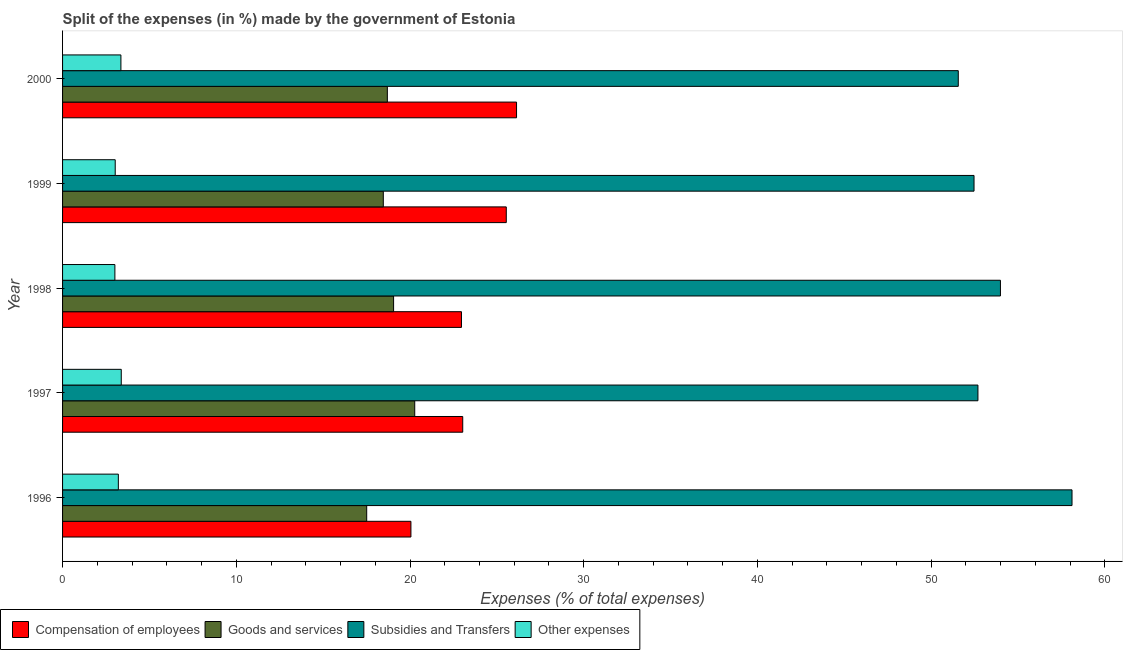Are the number of bars per tick equal to the number of legend labels?
Your answer should be very brief. Yes. Are the number of bars on each tick of the Y-axis equal?
Ensure brevity in your answer.  Yes. How many bars are there on the 2nd tick from the bottom?
Provide a short and direct response. 4. What is the label of the 4th group of bars from the top?
Your answer should be very brief. 1997. What is the percentage of amount spent on compensation of employees in 2000?
Ensure brevity in your answer.  26.13. Across all years, what is the maximum percentage of amount spent on goods and services?
Your answer should be compact. 20.27. Across all years, what is the minimum percentage of amount spent on other expenses?
Your answer should be compact. 3.01. What is the total percentage of amount spent on compensation of employees in the graph?
Your answer should be very brief. 117.72. What is the difference between the percentage of amount spent on compensation of employees in 1996 and that in 1997?
Ensure brevity in your answer.  -2.98. What is the difference between the percentage of amount spent on other expenses in 1997 and the percentage of amount spent on goods and services in 1999?
Your response must be concise. -15.08. What is the average percentage of amount spent on subsidies per year?
Provide a short and direct response. 53.76. In the year 1999, what is the difference between the percentage of amount spent on compensation of employees and percentage of amount spent on goods and services?
Offer a very short reply. 7.08. What is the ratio of the percentage of amount spent on subsidies in 1997 to that in 2000?
Provide a short and direct response. 1.02. Is the percentage of amount spent on goods and services in 1998 less than that in 2000?
Your response must be concise. No. What is the difference between the highest and the second highest percentage of amount spent on goods and services?
Offer a very short reply. 1.22. What is the difference between the highest and the lowest percentage of amount spent on subsidies?
Keep it short and to the point. 6.55. In how many years, is the percentage of amount spent on goods and services greater than the average percentage of amount spent on goods and services taken over all years?
Your answer should be very brief. 2. Is the sum of the percentage of amount spent on compensation of employees in 1998 and 1999 greater than the maximum percentage of amount spent on goods and services across all years?
Your response must be concise. Yes. What does the 2nd bar from the top in 1999 represents?
Provide a short and direct response. Subsidies and Transfers. What does the 4th bar from the bottom in 1997 represents?
Offer a very short reply. Other expenses. How many bars are there?
Keep it short and to the point. 20. Are all the bars in the graph horizontal?
Offer a terse response. Yes. How many years are there in the graph?
Your response must be concise. 5. Are the values on the major ticks of X-axis written in scientific E-notation?
Offer a very short reply. No. Does the graph contain grids?
Give a very brief answer. No. Where does the legend appear in the graph?
Keep it short and to the point. Bottom left. How many legend labels are there?
Your answer should be very brief. 4. How are the legend labels stacked?
Provide a short and direct response. Horizontal. What is the title of the graph?
Make the answer very short. Split of the expenses (in %) made by the government of Estonia. Does "Public resource use" appear as one of the legend labels in the graph?
Offer a very short reply. No. What is the label or title of the X-axis?
Your answer should be very brief. Expenses (% of total expenses). What is the Expenses (% of total expenses) in Compensation of employees in 1996?
Give a very brief answer. 20.05. What is the Expenses (% of total expenses) of Goods and services in 1996?
Offer a very short reply. 17.51. What is the Expenses (% of total expenses) in Subsidies and Transfers in 1996?
Keep it short and to the point. 58.11. What is the Expenses (% of total expenses) of Other expenses in 1996?
Make the answer very short. 3.21. What is the Expenses (% of total expenses) in Compensation of employees in 1997?
Offer a terse response. 23.03. What is the Expenses (% of total expenses) in Goods and services in 1997?
Keep it short and to the point. 20.27. What is the Expenses (% of total expenses) of Subsidies and Transfers in 1997?
Provide a succinct answer. 52.69. What is the Expenses (% of total expenses) of Other expenses in 1997?
Offer a terse response. 3.38. What is the Expenses (% of total expenses) of Compensation of employees in 1998?
Offer a terse response. 22.96. What is the Expenses (% of total expenses) of Goods and services in 1998?
Make the answer very short. 19.05. What is the Expenses (% of total expenses) of Subsidies and Transfers in 1998?
Keep it short and to the point. 53.99. What is the Expenses (% of total expenses) of Other expenses in 1998?
Offer a very short reply. 3.01. What is the Expenses (% of total expenses) in Compensation of employees in 1999?
Keep it short and to the point. 25.54. What is the Expenses (% of total expenses) in Goods and services in 1999?
Your response must be concise. 18.46. What is the Expenses (% of total expenses) in Subsidies and Transfers in 1999?
Provide a succinct answer. 52.47. What is the Expenses (% of total expenses) of Other expenses in 1999?
Offer a terse response. 3.03. What is the Expenses (% of total expenses) of Compensation of employees in 2000?
Your response must be concise. 26.13. What is the Expenses (% of total expenses) of Goods and services in 2000?
Offer a very short reply. 18.7. What is the Expenses (% of total expenses) in Subsidies and Transfers in 2000?
Your answer should be very brief. 51.56. What is the Expenses (% of total expenses) of Other expenses in 2000?
Your answer should be very brief. 3.36. Across all years, what is the maximum Expenses (% of total expenses) in Compensation of employees?
Make the answer very short. 26.13. Across all years, what is the maximum Expenses (% of total expenses) in Goods and services?
Ensure brevity in your answer.  20.27. Across all years, what is the maximum Expenses (% of total expenses) of Subsidies and Transfers?
Offer a very short reply. 58.11. Across all years, what is the maximum Expenses (% of total expenses) in Other expenses?
Make the answer very short. 3.38. Across all years, what is the minimum Expenses (% of total expenses) in Compensation of employees?
Keep it short and to the point. 20.05. Across all years, what is the minimum Expenses (% of total expenses) of Goods and services?
Your answer should be compact. 17.51. Across all years, what is the minimum Expenses (% of total expenses) of Subsidies and Transfers?
Your answer should be very brief. 51.56. Across all years, what is the minimum Expenses (% of total expenses) in Other expenses?
Make the answer very short. 3.01. What is the total Expenses (% of total expenses) of Compensation of employees in the graph?
Provide a short and direct response. 117.72. What is the total Expenses (% of total expenses) of Goods and services in the graph?
Offer a very short reply. 93.99. What is the total Expenses (% of total expenses) of Subsidies and Transfers in the graph?
Your answer should be compact. 268.81. What is the total Expenses (% of total expenses) of Other expenses in the graph?
Provide a short and direct response. 15.99. What is the difference between the Expenses (% of total expenses) in Compensation of employees in 1996 and that in 1997?
Offer a very short reply. -2.98. What is the difference between the Expenses (% of total expenses) in Goods and services in 1996 and that in 1997?
Give a very brief answer. -2.76. What is the difference between the Expenses (% of total expenses) of Subsidies and Transfers in 1996 and that in 1997?
Ensure brevity in your answer.  5.42. What is the difference between the Expenses (% of total expenses) in Other expenses in 1996 and that in 1997?
Provide a succinct answer. -0.17. What is the difference between the Expenses (% of total expenses) in Compensation of employees in 1996 and that in 1998?
Provide a succinct answer. -2.91. What is the difference between the Expenses (% of total expenses) of Goods and services in 1996 and that in 1998?
Give a very brief answer. -1.55. What is the difference between the Expenses (% of total expenses) in Subsidies and Transfers in 1996 and that in 1998?
Your answer should be very brief. 4.12. What is the difference between the Expenses (% of total expenses) in Other expenses in 1996 and that in 1998?
Keep it short and to the point. 0.2. What is the difference between the Expenses (% of total expenses) of Compensation of employees in 1996 and that in 1999?
Make the answer very short. -5.49. What is the difference between the Expenses (% of total expenses) of Goods and services in 1996 and that in 1999?
Ensure brevity in your answer.  -0.96. What is the difference between the Expenses (% of total expenses) of Subsidies and Transfers in 1996 and that in 1999?
Your answer should be very brief. 5.64. What is the difference between the Expenses (% of total expenses) in Other expenses in 1996 and that in 1999?
Give a very brief answer. 0.18. What is the difference between the Expenses (% of total expenses) in Compensation of employees in 1996 and that in 2000?
Provide a short and direct response. -6.08. What is the difference between the Expenses (% of total expenses) of Goods and services in 1996 and that in 2000?
Your response must be concise. -1.19. What is the difference between the Expenses (% of total expenses) in Subsidies and Transfers in 1996 and that in 2000?
Your answer should be compact. 6.55. What is the difference between the Expenses (% of total expenses) in Other expenses in 1996 and that in 2000?
Ensure brevity in your answer.  -0.15. What is the difference between the Expenses (% of total expenses) in Compensation of employees in 1997 and that in 1998?
Your answer should be very brief. 0.07. What is the difference between the Expenses (% of total expenses) of Goods and services in 1997 and that in 1998?
Give a very brief answer. 1.22. What is the difference between the Expenses (% of total expenses) of Subsidies and Transfers in 1997 and that in 1998?
Provide a short and direct response. -1.3. What is the difference between the Expenses (% of total expenses) in Other expenses in 1997 and that in 1998?
Your response must be concise. 0.37. What is the difference between the Expenses (% of total expenses) of Compensation of employees in 1997 and that in 1999?
Ensure brevity in your answer.  -2.51. What is the difference between the Expenses (% of total expenses) of Goods and services in 1997 and that in 1999?
Provide a succinct answer. 1.81. What is the difference between the Expenses (% of total expenses) in Subsidies and Transfers in 1997 and that in 1999?
Make the answer very short. 0.22. What is the difference between the Expenses (% of total expenses) of Other expenses in 1997 and that in 1999?
Your answer should be compact. 0.35. What is the difference between the Expenses (% of total expenses) in Compensation of employees in 1997 and that in 2000?
Give a very brief answer. -3.1. What is the difference between the Expenses (% of total expenses) of Goods and services in 1997 and that in 2000?
Your answer should be very brief. 1.58. What is the difference between the Expenses (% of total expenses) in Subsidies and Transfers in 1997 and that in 2000?
Ensure brevity in your answer.  1.13. What is the difference between the Expenses (% of total expenses) in Other expenses in 1997 and that in 2000?
Provide a short and direct response. 0.02. What is the difference between the Expenses (% of total expenses) in Compensation of employees in 1998 and that in 1999?
Make the answer very short. -2.58. What is the difference between the Expenses (% of total expenses) in Goods and services in 1998 and that in 1999?
Make the answer very short. 0.59. What is the difference between the Expenses (% of total expenses) in Subsidies and Transfers in 1998 and that in 1999?
Offer a very short reply. 1.52. What is the difference between the Expenses (% of total expenses) in Other expenses in 1998 and that in 1999?
Your answer should be compact. -0.02. What is the difference between the Expenses (% of total expenses) in Compensation of employees in 1998 and that in 2000?
Your answer should be very brief. -3.17. What is the difference between the Expenses (% of total expenses) of Goods and services in 1998 and that in 2000?
Offer a very short reply. 0.36. What is the difference between the Expenses (% of total expenses) of Subsidies and Transfers in 1998 and that in 2000?
Give a very brief answer. 2.43. What is the difference between the Expenses (% of total expenses) of Other expenses in 1998 and that in 2000?
Ensure brevity in your answer.  -0.35. What is the difference between the Expenses (% of total expenses) of Compensation of employees in 1999 and that in 2000?
Offer a very short reply. -0.59. What is the difference between the Expenses (% of total expenses) of Goods and services in 1999 and that in 2000?
Offer a very short reply. -0.23. What is the difference between the Expenses (% of total expenses) in Subsidies and Transfers in 1999 and that in 2000?
Your answer should be compact. 0.91. What is the difference between the Expenses (% of total expenses) in Other expenses in 1999 and that in 2000?
Provide a short and direct response. -0.33. What is the difference between the Expenses (% of total expenses) of Compensation of employees in 1996 and the Expenses (% of total expenses) of Goods and services in 1997?
Give a very brief answer. -0.22. What is the difference between the Expenses (% of total expenses) of Compensation of employees in 1996 and the Expenses (% of total expenses) of Subsidies and Transfers in 1997?
Your answer should be compact. -32.64. What is the difference between the Expenses (% of total expenses) of Compensation of employees in 1996 and the Expenses (% of total expenses) of Other expenses in 1997?
Provide a short and direct response. 16.67. What is the difference between the Expenses (% of total expenses) of Goods and services in 1996 and the Expenses (% of total expenses) of Subsidies and Transfers in 1997?
Make the answer very short. -35.18. What is the difference between the Expenses (% of total expenses) in Goods and services in 1996 and the Expenses (% of total expenses) in Other expenses in 1997?
Your response must be concise. 14.13. What is the difference between the Expenses (% of total expenses) in Subsidies and Transfers in 1996 and the Expenses (% of total expenses) in Other expenses in 1997?
Keep it short and to the point. 54.73. What is the difference between the Expenses (% of total expenses) in Compensation of employees in 1996 and the Expenses (% of total expenses) in Goods and services in 1998?
Make the answer very short. 1. What is the difference between the Expenses (% of total expenses) of Compensation of employees in 1996 and the Expenses (% of total expenses) of Subsidies and Transfers in 1998?
Offer a terse response. -33.93. What is the difference between the Expenses (% of total expenses) in Compensation of employees in 1996 and the Expenses (% of total expenses) in Other expenses in 1998?
Provide a short and direct response. 17.04. What is the difference between the Expenses (% of total expenses) of Goods and services in 1996 and the Expenses (% of total expenses) of Subsidies and Transfers in 1998?
Ensure brevity in your answer.  -36.48. What is the difference between the Expenses (% of total expenses) in Goods and services in 1996 and the Expenses (% of total expenses) in Other expenses in 1998?
Your response must be concise. 14.5. What is the difference between the Expenses (% of total expenses) in Subsidies and Transfers in 1996 and the Expenses (% of total expenses) in Other expenses in 1998?
Your answer should be very brief. 55.1. What is the difference between the Expenses (% of total expenses) of Compensation of employees in 1996 and the Expenses (% of total expenses) of Goods and services in 1999?
Ensure brevity in your answer.  1.59. What is the difference between the Expenses (% of total expenses) in Compensation of employees in 1996 and the Expenses (% of total expenses) in Subsidies and Transfers in 1999?
Give a very brief answer. -32.41. What is the difference between the Expenses (% of total expenses) of Compensation of employees in 1996 and the Expenses (% of total expenses) of Other expenses in 1999?
Keep it short and to the point. 17.02. What is the difference between the Expenses (% of total expenses) of Goods and services in 1996 and the Expenses (% of total expenses) of Subsidies and Transfers in 1999?
Offer a very short reply. -34.96. What is the difference between the Expenses (% of total expenses) in Goods and services in 1996 and the Expenses (% of total expenses) in Other expenses in 1999?
Offer a very short reply. 14.48. What is the difference between the Expenses (% of total expenses) of Subsidies and Transfers in 1996 and the Expenses (% of total expenses) of Other expenses in 1999?
Offer a very short reply. 55.08. What is the difference between the Expenses (% of total expenses) of Compensation of employees in 1996 and the Expenses (% of total expenses) of Goods and services in 2000?
Your response must be concise. 1.36. What is the difference between the Expenses (% of total expenses) in Compensation of employees in 1996 and the Expenses (% of total expenses) in Subsidies and Transfers in 2000?
Provide a short and direct response. -31.51. What is the difference between the Expenses (% of total expenses) of Compensation of employees in 1996 and the Expenses (% of total expenses) of Other expenses in 2000?
Provide a succinct answer. 16.69. What is the difference between the Expenses (% of total expenses) in Goods and services in 1996 and the Expenses (% of total expenses) in Subsidies and Transfers in 2000?
Make the answer very short. -34.05. What is the difference between the Expenses (% of total expenses) of Goods and services in 1996 and the Expenses (% of total expenses) of Other expenses in 2000?
Make the answer very short. 14.15. What is the difference between the Expenses (% of total expenses) of Subsidies and Transfers in 1996 and the Expenses (% of total expenses) of Other expenses in 2000?
Provide a succinct answer. 54.75. What is the difference between the Expenses (% of total expenses) of Compensation of employees in 1997 and the Expenses (% of total expenses) of Goods and services in 1998?
Your answer should be compact. 3.98. What is the difference between the Expenses (% of total expenses) in Compensation of employees in 1997 and the Expenses (% of total expenses) in Subsidies and Transfers in 1998?
Give a very brief answer. -30.95. What is the difference between the Expenses (% of total expenses) in Compensation of employees in 1997 and the Expenses (% of total expenses) in Other expenses in 1998?
Offer a terse response. 20.02. What is the difference between the Expenses (% of total expenses) of Goods and services in 1997 and the Expenses (% of total expenses) of Subsidies and Transfers in 1998?
Your answer should be very brief. -33.72. What is the difference between the Expenses (% of total expenses) of Goods and services in 1997 and the Expenses (% of total expenses) of Other expenses in 1998?
Your answer should be very brief. 17.26. What is the difference between the Expenses (% of total expenses) of Subsidies and Transfers in 1997 and the Expenses (% of total expenses) of Other expenses in 1998?
Give a very brief answer. 49.68. What is the difference between the Expenses (% of total expenses) of Compensation of employees in 1997 and the Expenses (% of total expenses) of Goods and services in 1999?
Make the answer very short. 4.57. What is the difference between the Expenses (% of total expenses) of Compensation of employees in 1997 and the Expenses (% of total expenses) of Subsidies and Transfers in 1999?
Offer a terse response. -29.43. What is the difference between the Expenses (% of total expenses) in Compensation of employees in 1997 and the Expenses (% of total expenses) in Other expenses in 1999?
Offer a terse response. 20. What is the difference between the Expenses (% of total expenses) in Goods and services in 1997 and the Expenses (% of total expenses) in Subsidies and Transfers in 1999?
Offer a terse response. -32.2. What is the difference between the Expenses (% of total expenses) of Goods and services in 1997 and the Expenses (% of total expenses) of Other expenses in 1999?
Offer a terse response. 17.24. What is the difference between the Expenses (% of total expenses) of Subsidies and Transfers in 1997 and the Expenses (% of total expenses) of Other expenses in 1999?
Keep it short and to the point. 49.66. What is the difference between the Expenses (% of total expenses) in Compensation of employees in 1997 and the Expenses (% of total expenses) in Goods and services in 2000?
Make the answer very short. 4.34. What is the difference between the Expenses (% of total expenses) in Compensation of employees in 1997 and the Expenses (% of total expenses) in Subsidies and Transfers in 2000?
Ensure brevity in your answer.  -28.53. What is the difference between the Expenses (% of total expenses) of Compensation of employees in 1997 and the Expenses (% of total expenses) of Other expenses in 2000?
Keep it short and to the point. 19.68. What is the difference between the Expenses (% of total expenses) of Goods and services in 1997 and the Expenses (% of total expenses) of Subsidies and Transfers in 2000?
Your answer should be compact. -31.29. What is the difference between the Expenses (% of total expenses) of Goods and services in 1997 and the Expenses (% of total expenses) of Other expenses in 2000?
Offer a very short reply. 16.91. What is the difference between the Expenses (% of total expenses) of Subsidies and Transfers in 1997 and the Expenses (% of total expenses) of Other expenses in 2000?
Give a very brief answer. 49.33. What is the difference between the Expenses (% of total expenses) of Compensation of employees in 1998 and the Expenses (% of total expenses) of Goods and services in 1999?
Offer a terse response. 4.5. What is the difference between the Expenses (% of total expenses) in Compensation of employees in 1998 and the Expenses (% of total expenses) in Subsidies and Transfers in 1999?
Offer a terse response. -29.51. What is the difference between the Expenses (% of total expenses) in Compensation of employees in 1998 and the Expenses (% of total expenses) in Other expenses in 1999?
Keep it short and to the point. 19.93. What is the difference between the Expenses (% of total expenses) of Goods and services in 1998 and the Expenses (% of total expenses) of Subsidies and Transfers in 1999?
Your answer should be compact. -33.41. What is the difference between the Expenses (% of total expenses) in Goods and services in 1998 and the Expenses (% of total expenses) in Other expenses in 1999?
Ensure brevity in your answer.  16.02. What is the difference between the Expenses (% of total expenses) in Subsidies and Transfers in 1998 and the Expenses (% of total expenses) in Other expenses in 1999?
Give a very brief answer. 50.96. What is the difference between the Expenses (% of total expenses) of Compensation of employees in 1998 and the Expenses (% of total expenses) of Goods and services in 2000?
Offer a terse response. 4.27. What is the difference between the Expenses (% of total expenses) of Compensation of employees in 1998 and the Expenses (% of total expenses) of Subsidies and Transfers in 2000?
Your answer should be compact. -28.6. What is the difference between the Expenses (% of total expenses) in Compensation of employees in 1998 and the Expenses (% of total expenses) in Other expenses in 2000?
Your answer should be very brief. 19.6. What is the difference between the Expenses (% of total expenses) of Goods and services in 1998 and the Expenses (% of total expenses) of Subsidies and Transfers in 2000?
Give a very brief answer. -32.51. What is the difference between the Expenses (% of total expenses) of Goods and services in 1998 and the Expenses (% of total expenses) of Other expenses in 2000?
Your response must be concise. 15.7. What is the difference between the Expenses (% of total expenses) of Subsidies and Transfers in 1998 and the Expenses (% of total expenses) of Other expenses in 2000?
Your answer should be very brief. 50.63. What is the difference between the Expenses (% of total expenses) of Compensation of employees in 1999 and the Expenses (% of total expenses) of Goods and services in 2000?
Offer a very short reply. 6.85. What is the difference between the Expenses (% of total expenses) in Compensation of employees in 1999 and the Expenses (% of total expenses) in Subsidies and Transfers in 2000?
Provide a short and direct response. -26.02. What is the difference between the Expenses (% of total expenses) of Compensation of employees in 1999 and the Expenses (% of total expenses) of Other expenses in 2000?
Give a very brief answer. 22.18. What is the difference between the Expenses (% of total expenses) of Goods and services in 1999 and the Expenses (% of total expenses) of Subsidies and Transfers in 2000?
Provide a short and direct response. -33.1. What is the difference between the Expenses (% of total expenses) in Goods and services in 1999 and the Expenses (% of total expenses) in Other expenses in 2000?
Offer a very short reply. 15.1. What is the difference between the Expenses (% of total expenses) of Subsidies and Transfers in 1999 and the Expenses (% of total expenses) of Other expenses in 2000?
Provide a short and direct response. 49.11. What is the average Expenses (% of total expenses) in Compensation of employees per year?
Your answer should be very brief. 23.54. What is the average Expenses (% of total expenses) in Goods and services per year?
Your response must be concise. 18.8. What is the average Expenses (% of total expenses) in Subsidies and Transfers per year?
Provide a short and direct response. 53.76. What is the average Expenses (% of total expenses) in Other expenses per year?
Keep it short and to the point. 3.2. In the year 1996, what is the difference between the Expenses (% of total expenses) in Compensation of employees and Expenses (% of total expenses) in Goods and services?
Keep it short and to the point. 2.55. In the year 1996, what is the difference between the Expenses (% of total expenses) in Compensation of employees and Expenses (% of total expenses) in Subsidies and Transfers?
Offer a very short reply. -38.06. In the year 1996, what is the difference between the Expenses (% of total expenses) of Compensation of employees and Expenses (% of total expenses) of Other expenses?
Keep it short and to the point. 16.84. In the year 1996, what is the difference between the Expenses (% of total expenses) of Goods and services and Expenses (% of total expenses) of Subsidies and Transfers?
Provide a succinct answer. -40.6. In the year 1996, what is the difference between the Expenses (% of total expenses) in Goods and services and Expenses (% of total expenses) in Other expenses?
Make the answer very short. 14.3. In the year 1996, what is the difference between the Expenses (% of total expenses) of Subsidies and Transfers and Expenses (% of total expenses) of Other expenses?
Provide a short and direct response. 54.9. In the year 1997, what is the difference between the Expenses (% of total expenses) of Compensation of employees and Expenses (% of total expenses) of Goods and services?
Provide a short and direct response. 2.76. In the year 1997, what is the difference between the Expenses (% of total expenses) in Compensation of employees and Expenses (% of total expenses) in Subsidies and Transfers?
Provide a short and direct response. -29.66. In the year 1997, what is the difference between the Expenses (% of total expenses) of Compensation of employees and Expenses (% of total expenses) of Other expenses?
Offer a terse response. 19.66. In the year 1997, what is the difference between the Expenses (% of total expenses) of Goods and services and Expenses (% of total expenses) of Subsidies and Transfers?
Your response must be concise. -32.42. In the year 1997, what is the difference between the Expenses (% of total expenses) in Goods and services and Expenses (% of total expenses) in Other expenses?
Your answer should be compact. 16.89. In the year 1997, what is the difference between the Expenses (% of total expenses) in Subsidies and Transfers and Expenses (% of total expenses) in Other expenses?
Provide a succinct answer. 49.31. In the year 1998, what is the difference between the Expenses (% of total expenses) in Compensation of employees and Expenses (% of total expenses) in Goods and services?
Provide a short and direct response. 3.91. In the year 1998, what is the difference between the Expenses (% of total expenses) in Compensation of employees and Expenses (% of total expenses) in Subsidies and Transfers?
Make the answer very short. -31.02. In the year 1998, what is the difference between the Expenses (% of total expenses) of Compensation of employees and Expenses (% of total expenses) of Other expenses?
Give a very brief answer. 19.95. In the year 1998, what is the difference between the Expenses (% of total expenses) in Goods and services and Expenses (% of total expenses) in Subsidies and Transfers?
Keep it short and to the point. -34.93. In the year 1998, what is the difference between the Expenses (% of total expenses) of Goods and services and Expenses (% of total expenses) of Other expenses?
Your answer should be very brief. 16.04. In the year 1998, what is the difference between the Expenses (% of total expenses) of Subsidies and Transfers and Expenses (% of total expenses) of Other expenses?
Your answer should be compact. 50.98. In the year 1999, what is the difference between the Expenses (% of total expenses) in Compensation of employees and Expenses (% of total expenses) in Goods and services?
Your response must be concise. 7.08. In the year 1999, what is the difference between the Expenses (% of total expenses) in Compensation of employees and Expenses (% of total expenses) in Subsidies and Transfers?
Your response must be concise. -26.93. In the year 1999, what is the difference between the Expenses (% of total expenses) in Compensation of employees and Expenses (% of total expenses) in Other expenses?
Your response must be concise. 22.51. In the year 1999, what is the difference between the Expenses (% of total expenses) of Goods and services and Expenses (% of total expenses) of Subsidies and Transfers?
Make the answer very short. -34. In the year 1999, what is the difference between the Expenses (% of total expenses) in Goods and services and Expenses (% of total expenses) in Other expenses?
Offer a terse response. 15.43. In the year 1999, what is the difference between the Expenses (% of total expenses) of Subsidies and Transfers and Expenses (% of total expenses) of Other expenses?
Give a very brief answer. 49.44. In the year 2000, what is the difference between the Expenses (% of total expenses) of Compensation of employees and Expenses (% of total expenses) of Goods and services?
Provide a succinct answer. 7.44. In the year 2000, what is the difference between the Expenses (% of total expenses) in Compensation of employees and Expenses (% of total expenses) in Subsidies and Transfers?
Provide a short and direct response. -25.43. In the year 2000, what is the difference between the Expenses (% of total expenses) in Compensation of employees and Expenses (% of total expenses) in Other expenses?
Offer a very short reply. 22.77. In the year 2000, what is the difference between the Expenses (% of total expenses) of Goods and services and Expenses (% of total expenses) of Subsidies and Transfers?
Provide a succinct answer. -32.87. In the year 2000, what is the difference between the Expenses (% of total expenses) of Goods and services and Expenses (% of total expenses) of Other expenses?
Ensure brevity in your answer.  15.34. In the year 2000, what is the difference between the Expenses (% of total expenses) of Subsidies and Transfers and Expenses (% of total expenses) of Other expenses?
Offer a terse response. 48.2. What is the ratio of the Expenses (% of total expenses) of Compensation of employees in 1996 to that in 1997?
Give a very brief answer. 0.87. What is the ratio of the Expenses (% of total expenses) of Goods and services in 1996 to that in 1997?
Offer a very short reply. 0.86. What is the ratio of the Expenses (% of total expenses) of Subsidies and Transfers in 1996 to that in 1997?
Your answer should be compact. 1.1. What is the ratio of the Expenses (% of total expenses) of Other expenses in 1996 to that in 1997?
Provide a succinct answer. 0.95. What is the ratio of the Expenses (% of total expenses) of Compensation of employees in 1996 to that in 1998?
Your answer should be compact. 0.87. What is the ratio of the Expenses (% of total expenses) in Goods and services in 1996 to that in 1998?
Offer a very short reply. 0.92. What is the ratio of the Expenses (% of total expenses) of Subsidies and Transfers in 1996 to that in 1998?
Keep it short and to the point. 1.08. What is the ratio of the Expenses (% of total expenses) of Other expenses in 1996 to that in 1998?
Provide a short and direct response. 1.07. What is the ratio of the Expenses (% of total expenses) in Compensation of employees in 1996 to that in 1999?
Give a very brief answer. 0.79. What is the ratio of the Expenses (% of total expenses) of Goods and services in 1996 to that in 1999?
Offer a very short reply. 0.95. What is the ratio of the Expenses (% of total expenses) in Subsidies and Transfers in 1996 to that in 1999?
Make the answer very short. 1.11. What is the ratio of the Expenses (% of total expenses) of Other expenses in 1996 to that in 1999?
Ensure brevity in your answer.  1.06. What is the ratio of the Expenses (% of total expenses) of Compensation of employees in 1996 to that in 2000?
Offer a terse response. 0.77. What is the ratio of the Expenses (% of total expenses) of Goods and services in 1996 to that in 2000?
Your answer should be compact. 0.94. What is the ratio of the Expenses (% of total expenses) of Subsidies and Transfers in 1996 to that in 2000?
Your answer should be compact. 1.13. What is the ratio of the Expenses (% of total expenses) in Other expenses in 1996 to that in 2000?
Keep it short and to the point. 0.96. What is the ratio of the Expenses (% of total expenses) of Goods and services in 1997 to that in 1998?
Make the answer very short. 1.06. What is the ratio of the Expenses (% of total expenses) in Subsidies and Transfers in 1997 to that in 1998?
Ensure brevity in your answer.  0.98. What is the ratio of the Expenses (% of total expenses) of Other expenses in 1997 to that in 1998?
Your answer should be compact. 1.12. What is the ratio of the Expenses (% of total expenses) of Compensation of employees in 1997 to that in 1999?
Make the answer very short. 0.9. What is the ratio of the Expenses (% of total expenses) of Goods and services in 1997 to that in 1999?
Your answer should be very brief. 1.1. What is the ratio of the Expenses (% of total expenses) in Other expenses in 1997 to that in 1999?
Offer a very short reply. 1.11. What is the ratio of the Expenses (% of total expenses) in Compensation of employees in 1997 to that in 2000?
Your answer should be very brief. 0.88. What is the ratio of the Expenses (% of total expenses) in Goods and services in 1997 to that in 2000?
Provide a succinct answer. 1.08. What is the ratio of the Expenses (% of total expenses) in Subsidies and Transfers in 1997 to that in 2000?
Offer a terse response. 1.02. What is the ratio of the Expenses (% of total expenses) of Other expenses in 1997 to that in 2000?
Offer a very short reply. 1.01. What is the ratio of the Expenses (% of total expenses) of Compensation of employees in 1998 to that in 1999?
Provide a succinct answer. 0.9. What is the ratio of the Expenses (% of total expenses) in Goods and services in 1998 to that in 1999?
Provide a short and direct response. 1.03. What is the ratio of the Expenses (% of total expenses) of Compensation of employees in 1998 to that in 2000?
Keep it short and to the point. 0.88. What is the ratio of the Expenses (% of total expenses) in Goods and services in 1998 to that in 2000?
Offer a very short reply. 1.02. What is the ratio of the Expenses (% of total expenses) of Subsidies and Transfers in 1998 to that in 2000?
Provide a short and direct response. 1.05. What is the ratio of the Expenses (% of total expenses) in Other expenses in 1998 to that in 2000?
Offer a very short reply. 0.9. What is the ratio of the Expenses (% of total expenses) in Compensation of employees in 1999 to that in 2000?
Offer a very short reply. 0.98. What is the ratio of the Expenses (% of total expenses) of Goods and services in 1999 to that in 2000?
Your answer should be compact. 0.99. What is the ratio of the Expenses (% of total expenses) of Subsidies and Transfers in 1999 to that in 2000?
Give a very brief answer. 1.02. What is the ratio of the Expenses (% of total expenses) in Other expenses in 1999 to that in 2000?
Your answer should be compact. 0.9. What is the difference between the highest and the second highest Expenses (% of total expenses) of Compensation of employees?
Your answer should be compact. 0.59. What is the difference between the highest and the second highest Expenses (% of total expenses) of Goods and services?
Offer a very short reply. 1.22. What is the difference between the highest and the second highest Expenses (% of total expenses) of Subsidies and Transfers?
Provide a succinct answer. 4.12. What is the difference between the highest and the second highest Expenses (% of total expenses) in Other expenses?
Your response must be concise. 0.02. What is the difference between the highest and the lowest Expenses (% of total expenses) of Compensation of employees?
Keep it short and to the point. 6.08. What is the difference between the highest and the lowest Expenses (% of total expenses) of Goods and services?
Your answer should be very brief. 2.76. What is the difference between the highest and the lowest Expenses (% of total expenses) of Subsidies and Transfers?
Offer a terse response. 6.55. What is the difference between the highest and the lowest Expenses (% of total expenses) in Other expenses?
Provide a succinct answer. 0.37. 